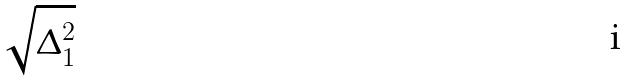Convert formula to latex. <formula><loc_0><loc_0><loc_500><loc_500>\sqrt { \Delta _ { 1 } ^ { 2 } }</formula> 